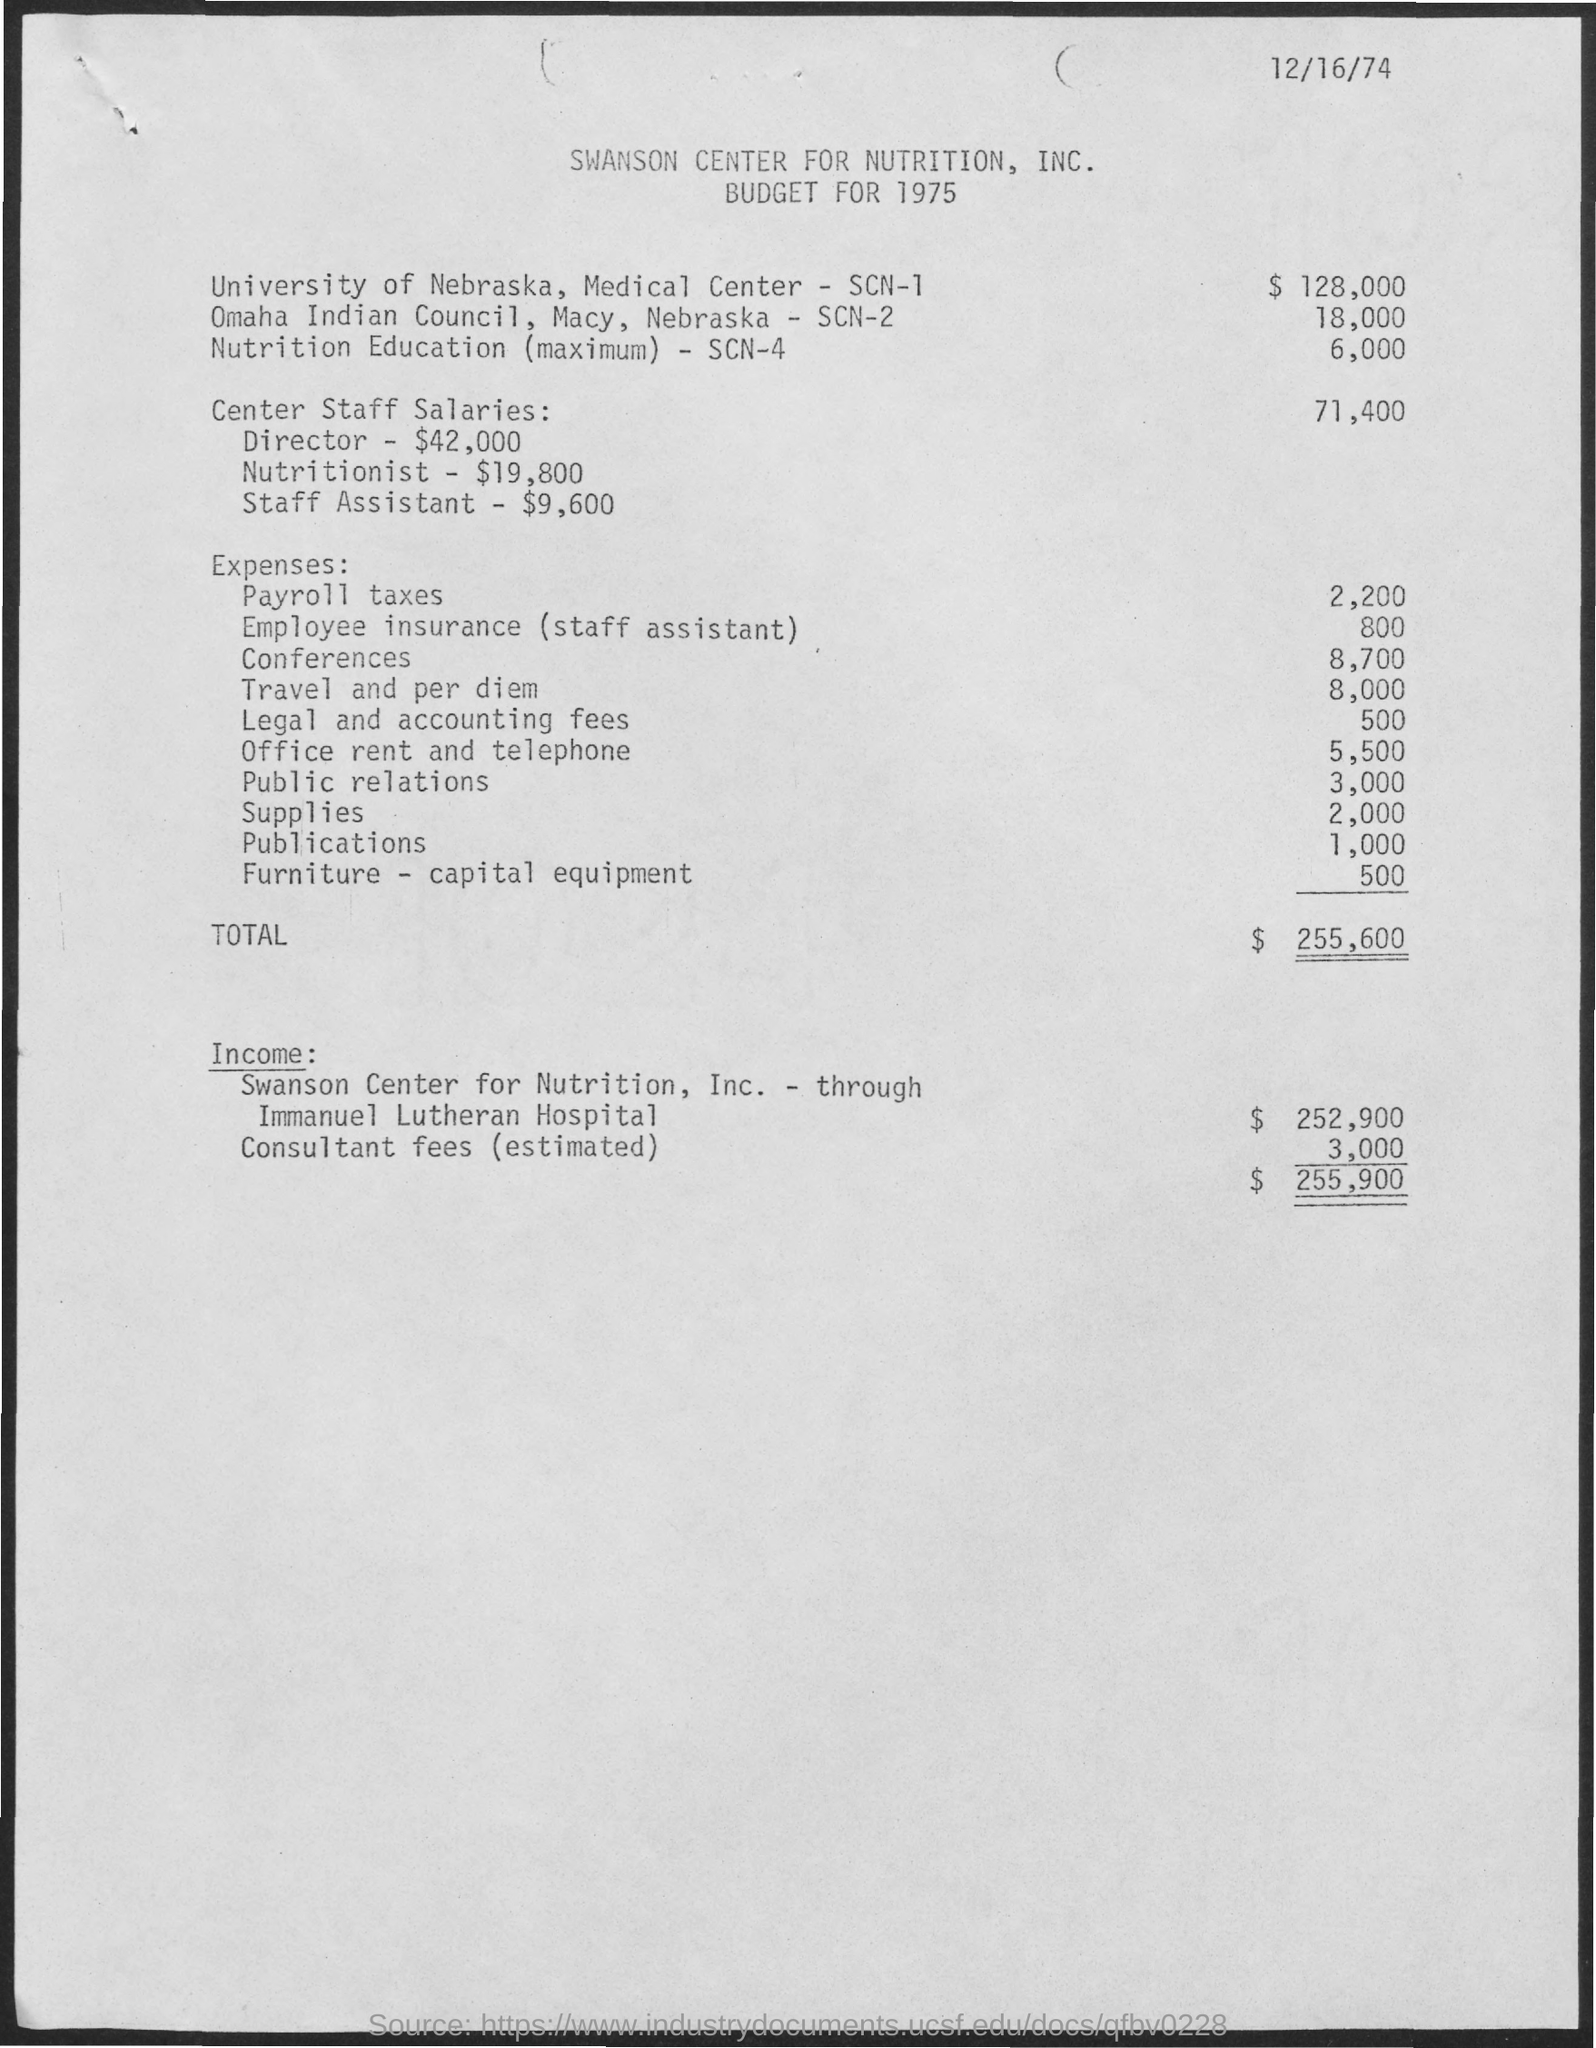What is the date on the document?
Make the answer very short. 12/16/74. What is the center staff salaries?
Your response must be concise. 71,400. What are the expenses for Payroll taxes?
Give a very brief answer. 2,200. What are the expenses for Conferences?
Ensure brevity in your answer.  8,700. What are the expenses for Travel and per diem?
Give a very brief answer. 8,000. What are the expenses for Office rent and telephone?
Your response must be concise. 5,500. What are the expenses for Public relations?
Give a very brief answer. 3,000. What are the expenses for Supplies?
Provide a succinct answer. 2,000. What are the Total expenses ?
Ensure brevity in your answer.  $ 255,600. What are the expenses for Publications?
Your answer should be very brief. 1,000. 